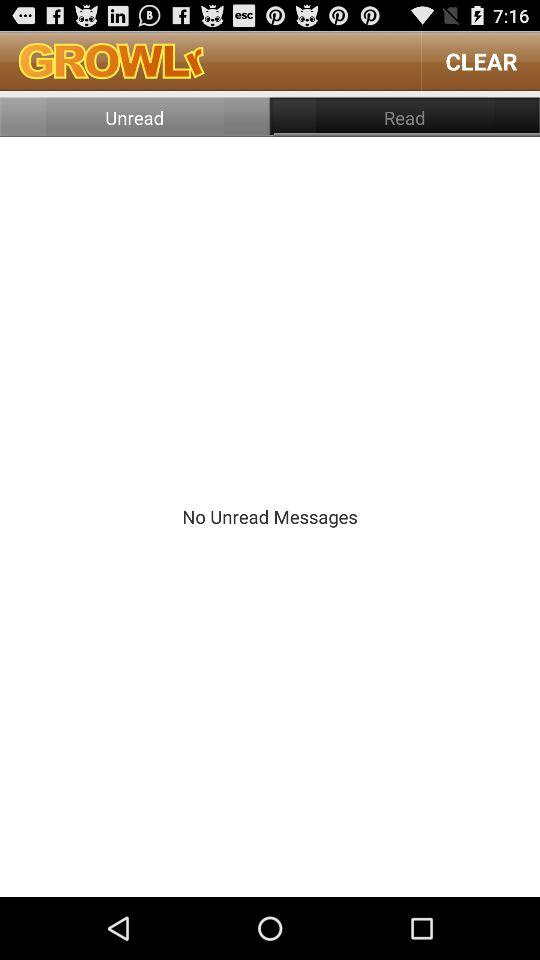How many unread messages does the user have?
Answer the question using a single word or phrase. 0 